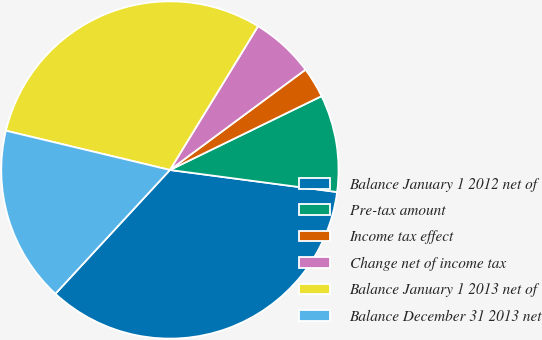Convert chart to OTSL. <chart><loc_0><loc_0><loc_500><loc_500><pie_chart><fcel>Balance January 1 2012 net of<fcel>Pre-tax amount<fcel>Income tax effect<fcel>Change net of income tax<fcel>Balance January 1 2013 net of<fcel>Balance December 31 2013 net<nl><fcel>34.79%<fcel>9.3%<fcel>2.93%<fcel>6.11%<fcel>30.01%<fcel>16.86%<nl></chart> 